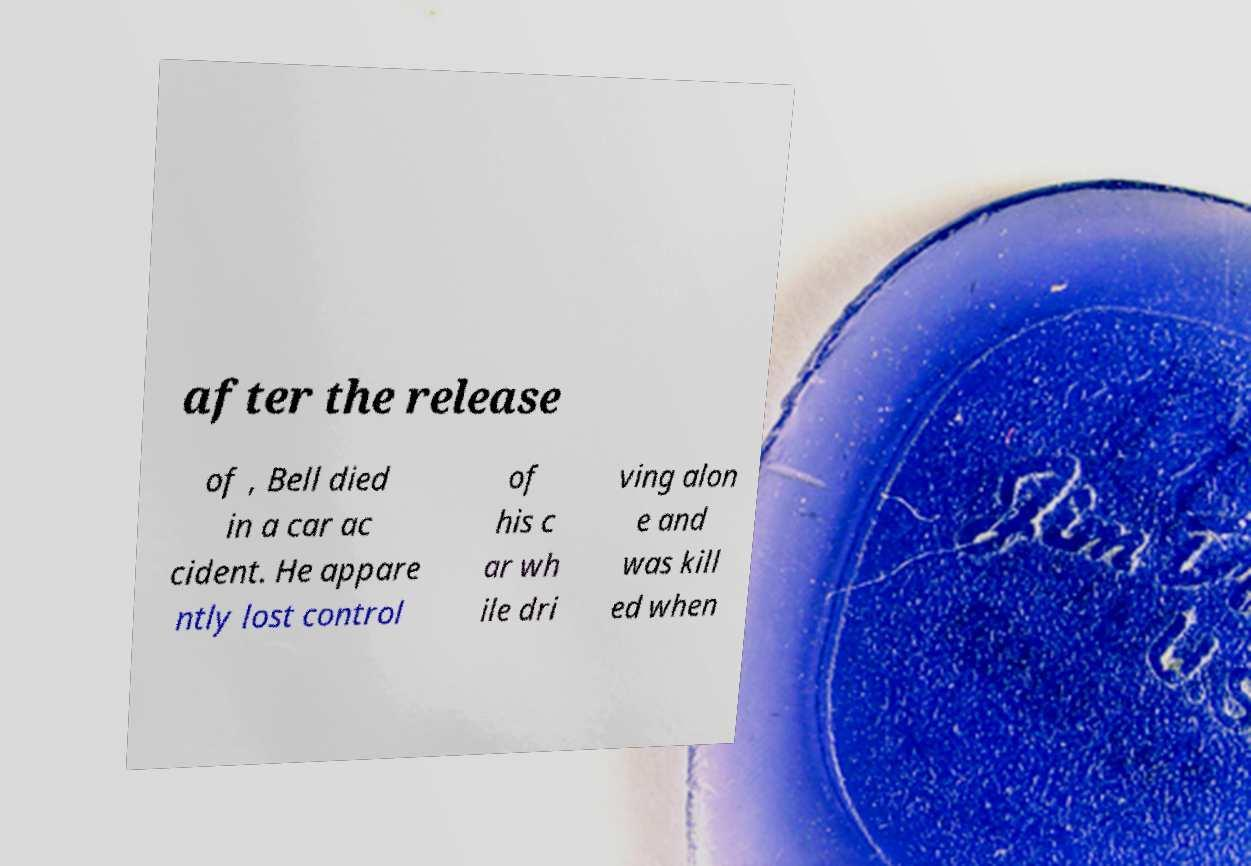Can you accurately transcribe the text from the provided image for me? after the release of , Bell died in a car ac cident. He appare ntly lost control of his c ar wh ile dri ving alon e and was kill ed when 